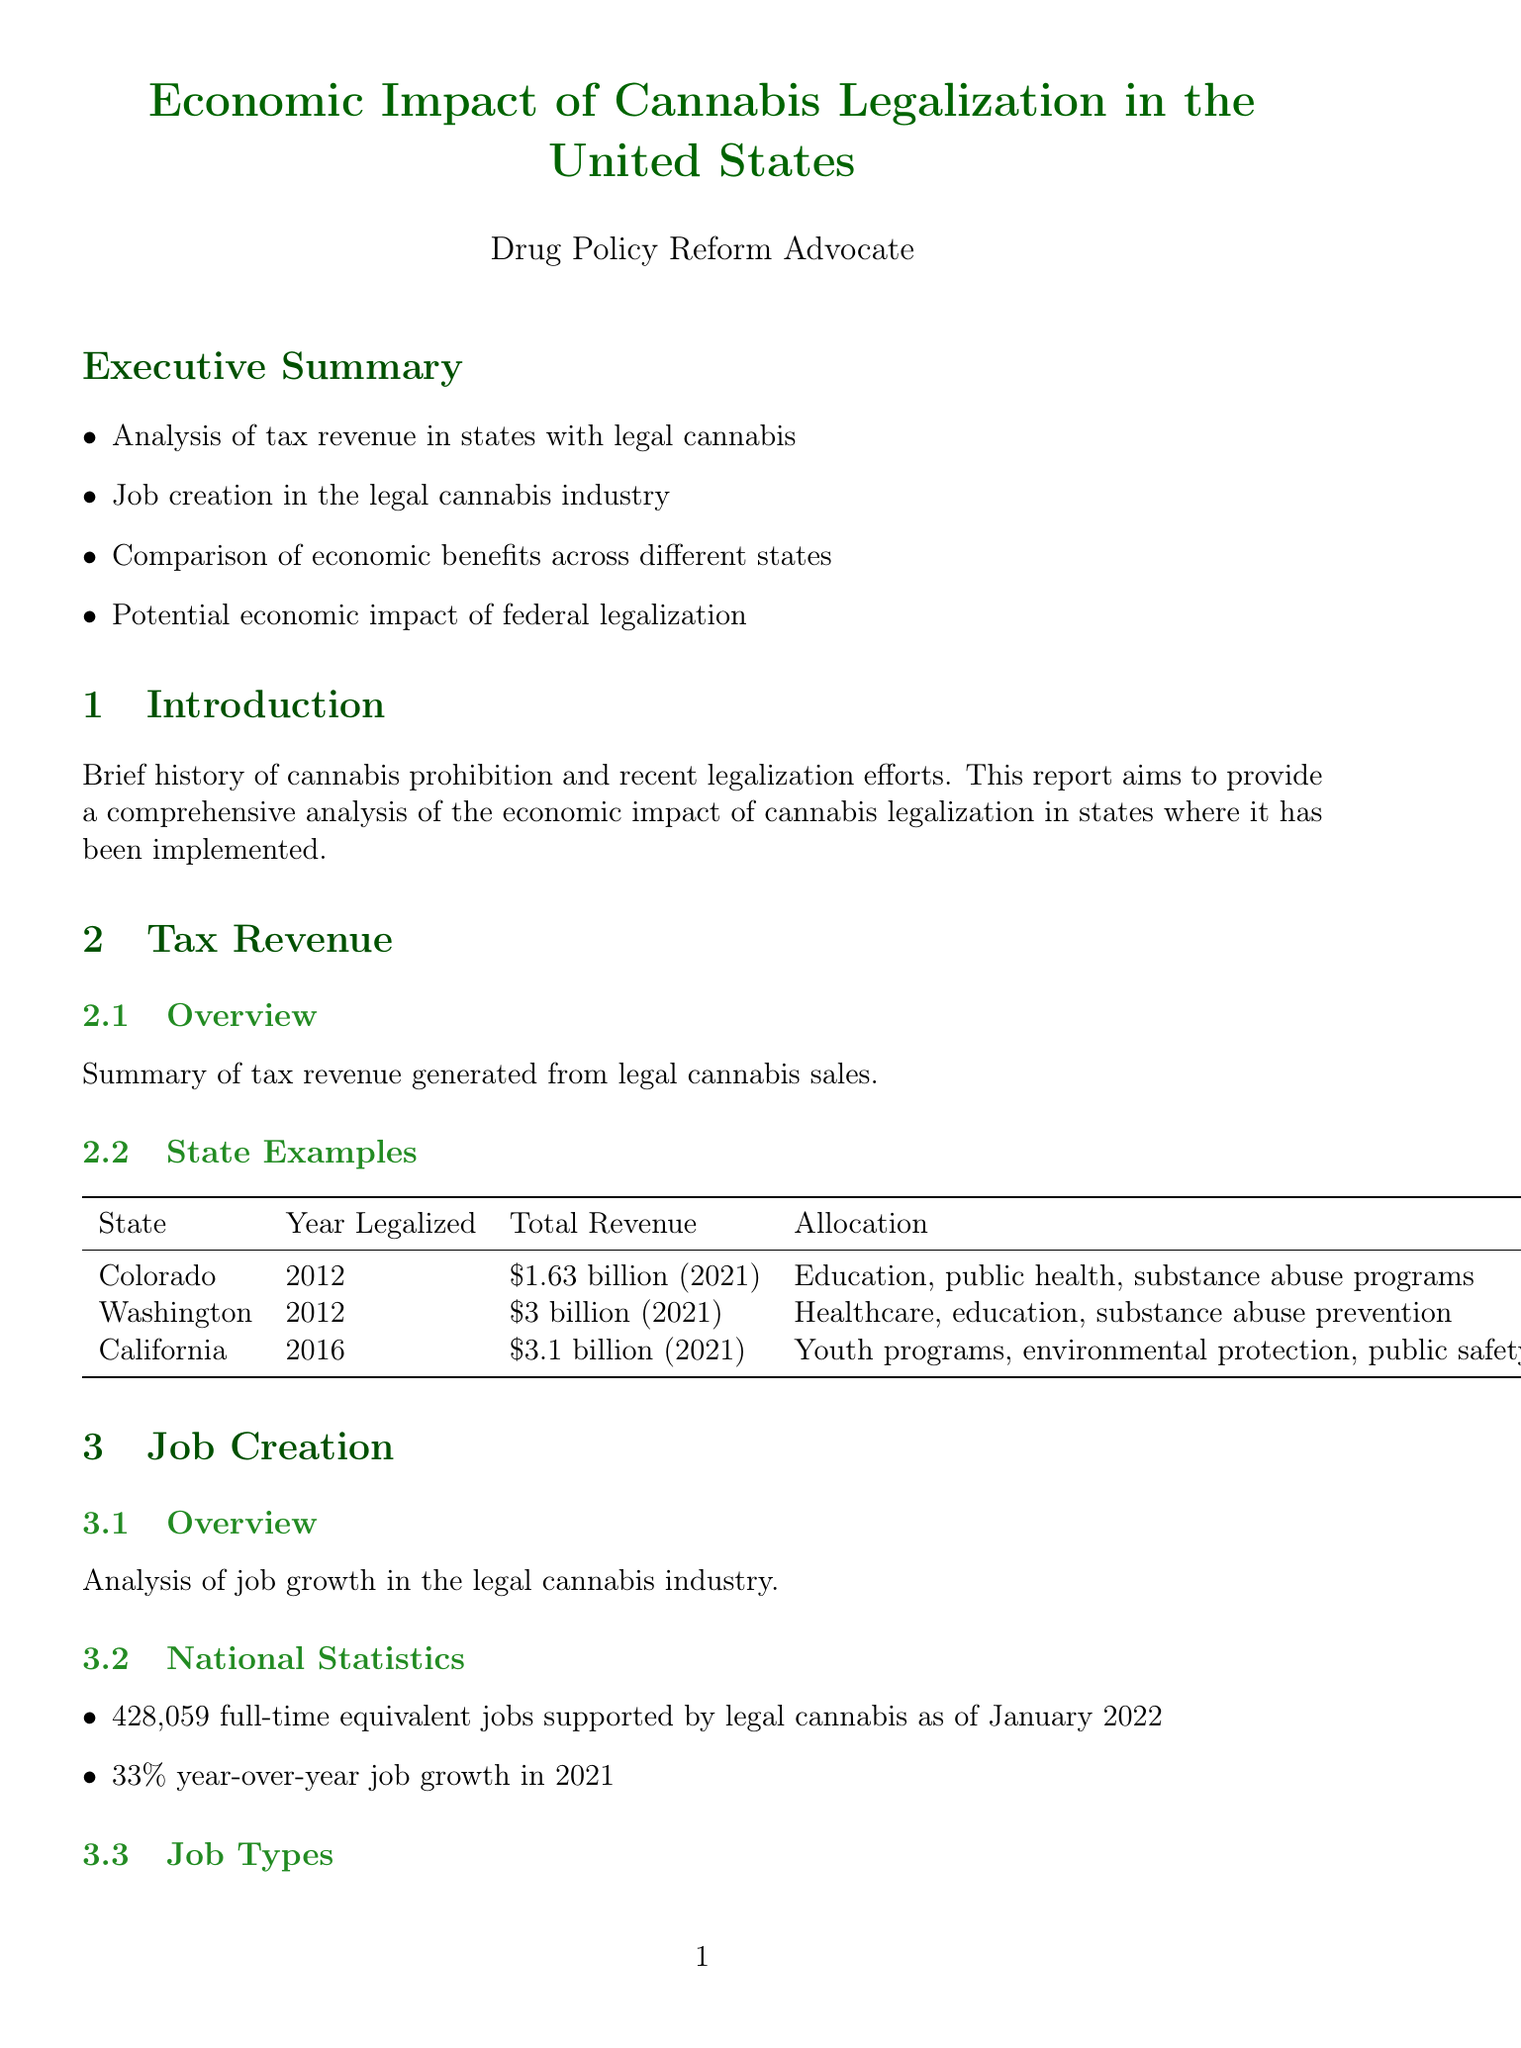What is the total tax revenue in Colorado? The total tax revenue in Colorado from legal cannabis sales is reported as of 2021.
Answer: $1.63 billion (as of 2021) What industry supported 428059 jobs as of January 2022? This figure pertains to the job growth in the legal cannabis industry, which supported this number of jobs.
Answer: Legal cannabis industry What year was cannabis legalized in California? The document states that California legalized cannabis in 2016.
Answer: 2016 What is the projected market value of the U.S. cannabis market by 2030? This projection is mentioned in the federal legalization projections section detailing expected economic growth.
Answer: $100 billion Which state allocated cannabis tax revenue to youth programs? The report provides examples of states and how they allocate legal cannabis tax revenue, and California is noted for this allocation.
Answer: California What type of job had a 33% growth rate in 2021? The growth rate pertains to total jobs in the legal cannabis sector, demonstrating industry expansion.
Answer: Total jobs What complex issue is mentioned that affects banking services? The document outlines the financial constraints that arise from the federal prohibition of cannabis affecting banking.
Answer: Federal prohibition How much revenue is expected from federal legalization over the next decade? The document cites an estimate from the Congressional Budget Office indicating potential tax revenue.
Answer: $128.8 billion What role do social equity programs play in Illinois? The document mentions that these programs aim to create opportunities for communities affected by the War on Drugs.
Answer: Creation of opportunities 